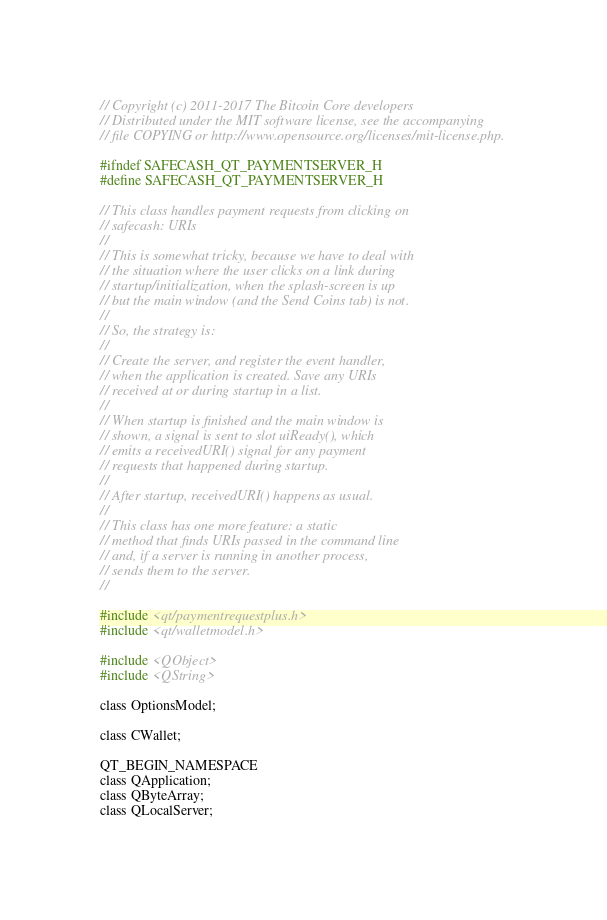Convert code to text. <code><loc_0><loc_0><loc_500><loc_500><_C_>// Copyright (c) 2011-2017 The Bitcoin Core developers
// Distributed under the MIT software license, see the accompanying
// file COPYING or http://www.opensource.org/licenses/mit-license.php.

#ifndef SAFECASH_QT_PAYMENTSERVER_H
#define SAFECASH_QT_PAYMENTSERVER_H

// This class handles payment requests from clicking on
// safecash: URIs
//
// This is somewhat tricky, because we have to deal with
// the situation where the user clicks on a link during
// startup/initialization, when the splash-screen is up
// but the main window (and the Send Coins tab) is not.
//
// So, the strategy is:
//
// Create the server, and register the event handler,
// when the application is created. Save any URIs
// received at or during startup in a list.
//
// When startup is finished and the main window is
// shown, a signal is sent to slot uiReady(), which
// emits a receivedURI() signal for any payment
// requests that happened during startup.
//
// After startup, receivedURI() happens as usual.
//
// This class has one more feature: a static
// method that finds URIs passed in the command line
// and, if a server is running in another process,
// sends them to the server.
//

#include <qt/paymentrequestplus.h>
#include <qt/walletmodel.h>

#include <QObject>
#include <QString>

class OptionsModel;

class CWallet;

QT_BEGIN_NAMESPACE
class QApplication;
class QByteArray;
class QLocalServer;</code> 